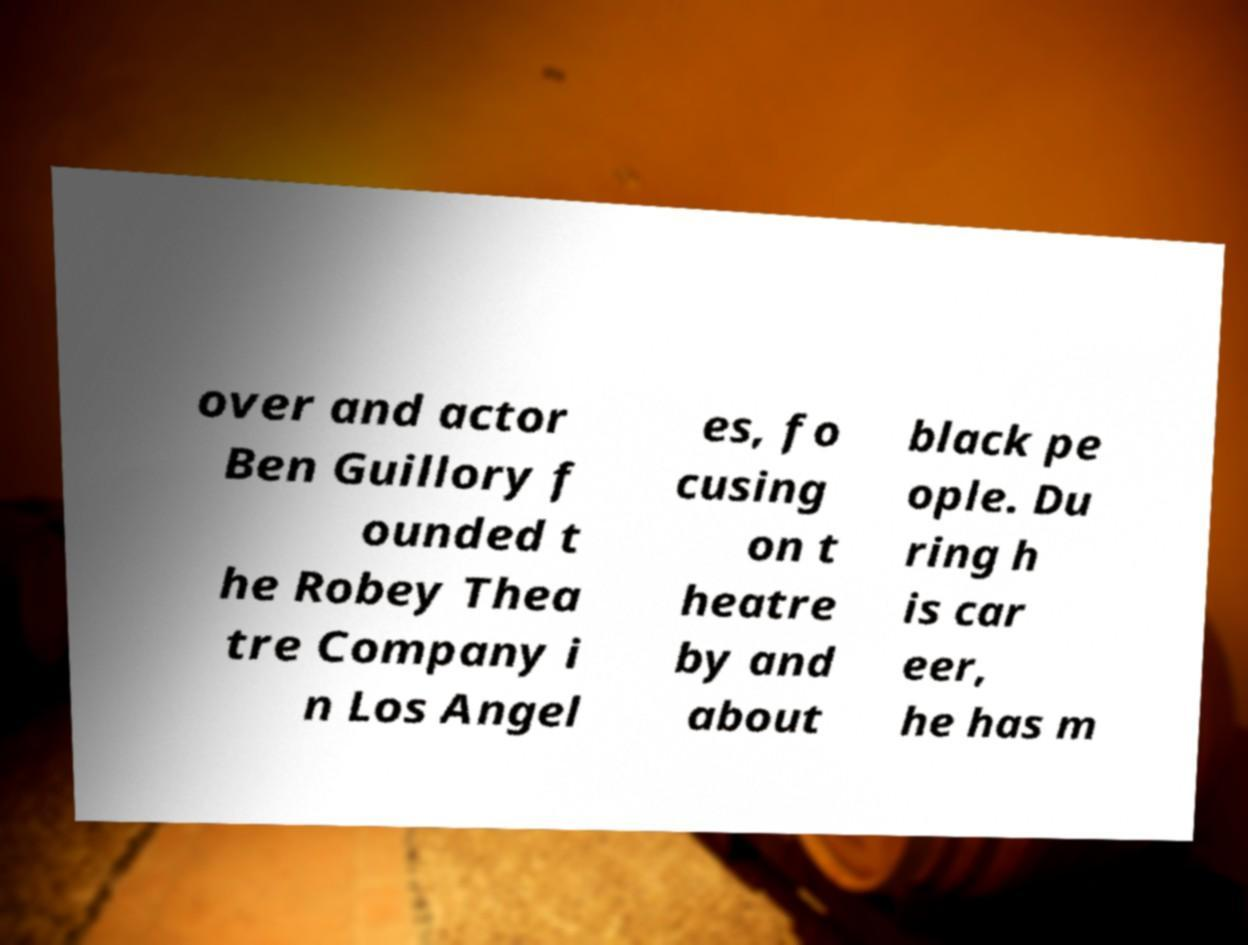What messages or text are displayed in this image? I need them in a readable, typed format. over and actor Ben Guillory f ounded t he Robey Thea tre Company i n Los Angel es, fo cusing on t heatre by and about black pe ople. Du ring h is car eer, he has m 